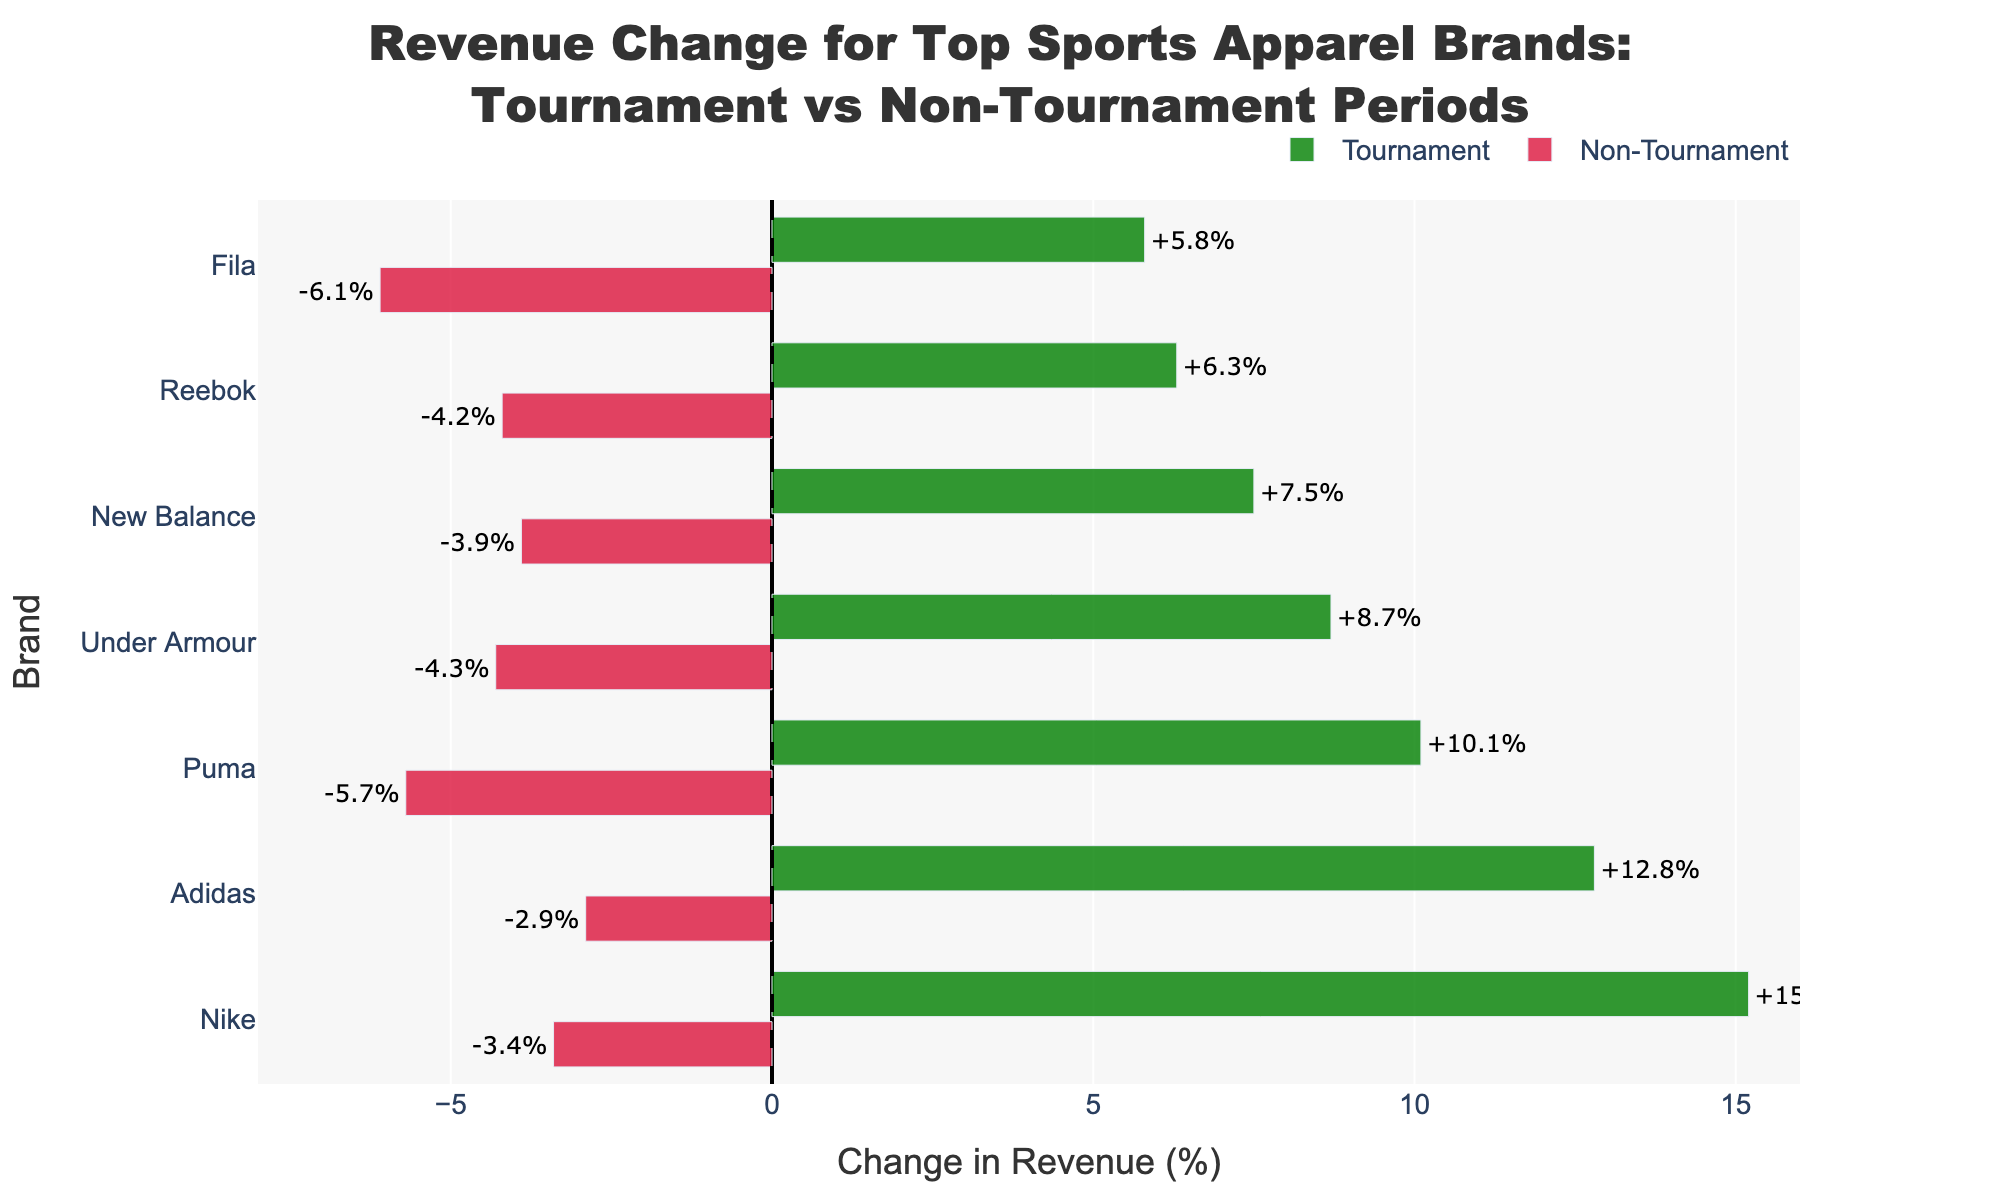Which brand sees the highest increase in revenue during tournament periods? The tallest green bar represents Nike, which has the highest increase in revenue during the tournament period at +15.2%.
Answer: Nike Which brand has the smallest revenue change during tournament periods? The shortest green bar belongs to Fila, indicating the smallest increase in revenue at +5.8%.
Answer: Fila How does Nike's revenue change in non-tournament periods compare to Adidas' revenue change in the same period? Nike has a non-tournament period change of -3.4%, while Adidas' non-tournament change is -2.9%. This shows that Nike's revenue decrease is slightly larger.
Answer: Nike's decrease is larger What is the average revenue change for all brands during non-tournament periods? Sum the non-tournament changes and divide by the number of brands: (-3.4 - 2.9 - 5.7 - 4.3 - 3.9 - 4.2 - 6.1)/7 = -4.36%.
Answer: -4.36% Which brand has the largest difference in revenue change between tournament and non-tournament periods? Calculate the difference for each brand and find the largest: Nike: 15.2 - (-3.4) = 18.6, Adidas: 12.8 - (-2.9) = 15.7, Puma: 10.1 - (-5.7) = 15.8, Under Armour: 8.7 - (-4.3) = 13, New Balance: 7.5 - (-3.9) = 11.4, Reebok: 6.3 - (-4.2) = 10.5, Fila: 5.8 - (-6.1) = 11.9. Hence, Nike has the largest difference.
Answer: Nike Compare the overall trend in revenue changes between tournament and non-tournament periods for all brands. All brands show increased revenues during tournaments (green bars) and decreased revenues in non-tournament periods (red bars).
Answer: Tournament increases, Non-Tournament decreases Which brands have a more than 10% increase in revenue during tournaments? Checking the green bars: Nike (+15.2%), Adidas (+12.8%), and Puma (+10.1%) show more than 10% increases.
Answer: Nike, Adidas, Puma What is the combined revenue change for Adidas and Reebok during non-tournament periods? Add the non-tournament changes of Adidas (-2.9%) and Reebok (-4.2%): -2.9 + -4.2 = -7.1%.
Answer: -7.1% How does Under Armour's revenue change during tournaments compare to Fila's during the same period? Under Armour shows an increase of +8.7%, while Fila shows an increase of +5.8%.
Answer: Under Armour's increase is higher 